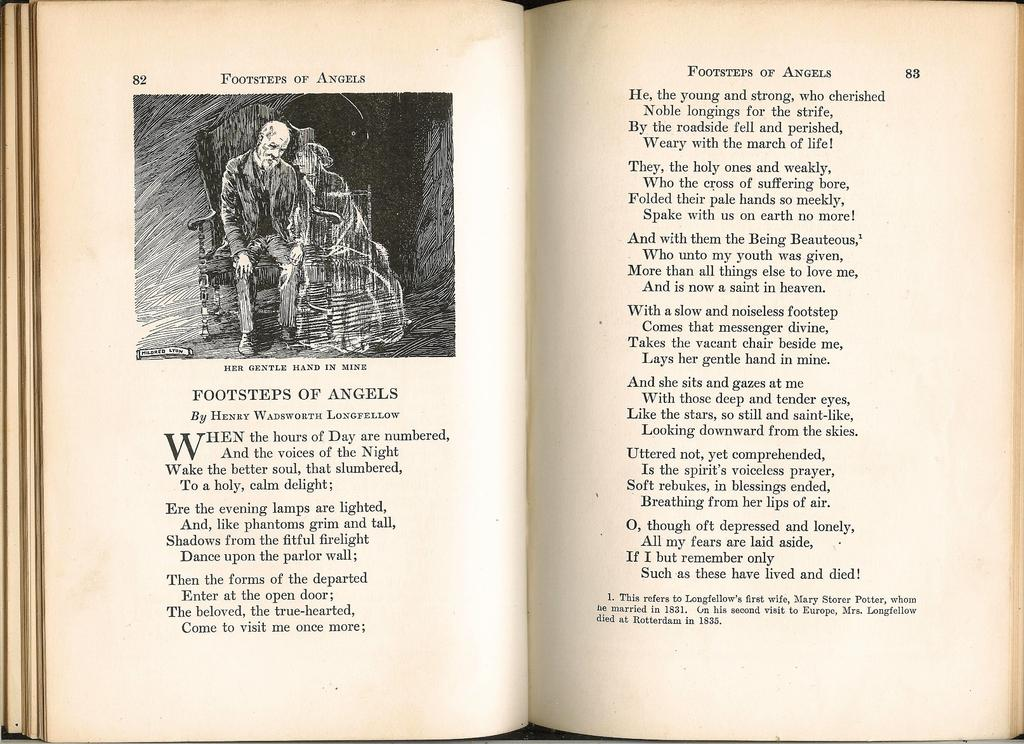What object is present in the image? There is a book in the image. What can be found within the book? The book contains an illustration or image of two people sitting on a chair. How many bikes are parked next to the chair in the image? There are no bikes present in the image; it only features an illustration or image of two people sitting on a chair within a book. 